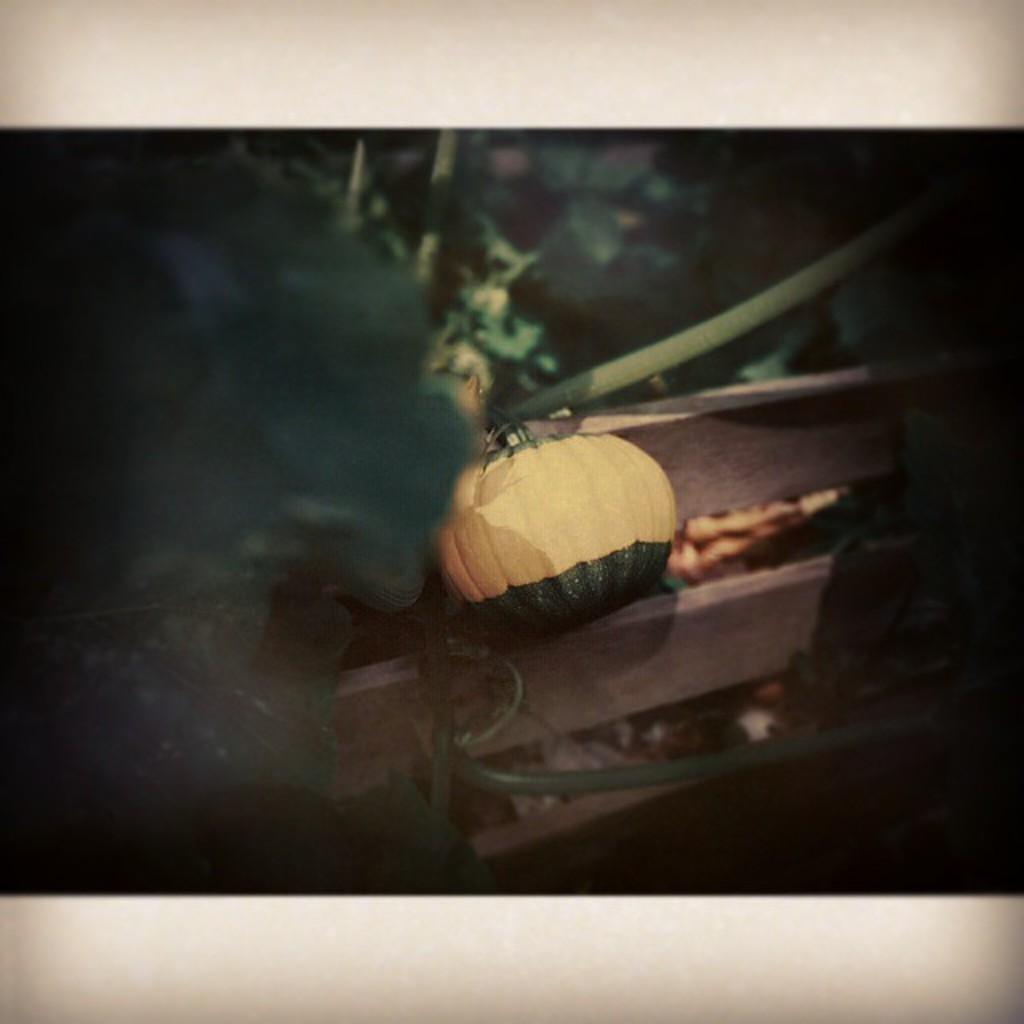What is the main object in the image? There is a pumpkin in the image. How is the pumpkin attached or secured? The pumpkin is tied to a wooden fence. What other object can be seen in the image? There is a pipe in the image. What can be seen in the background of the image? There are plants in the background of the image. What is the color of the plants? The plants are green in color. What type of test is being conducted on the pumpkin in the image? There is no test being conducted on the pumpkin in the image; it is simply tied to a wooden fence. How many adjustments have been made to the church in the image? There is no church present in the image, so it is not possible to determine if any adjustments have been made. 